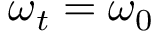<formula> <loc_0><loc_0><loc_500><loc_500>\omega _ { t } = \omega _ { 0 }</formula> 